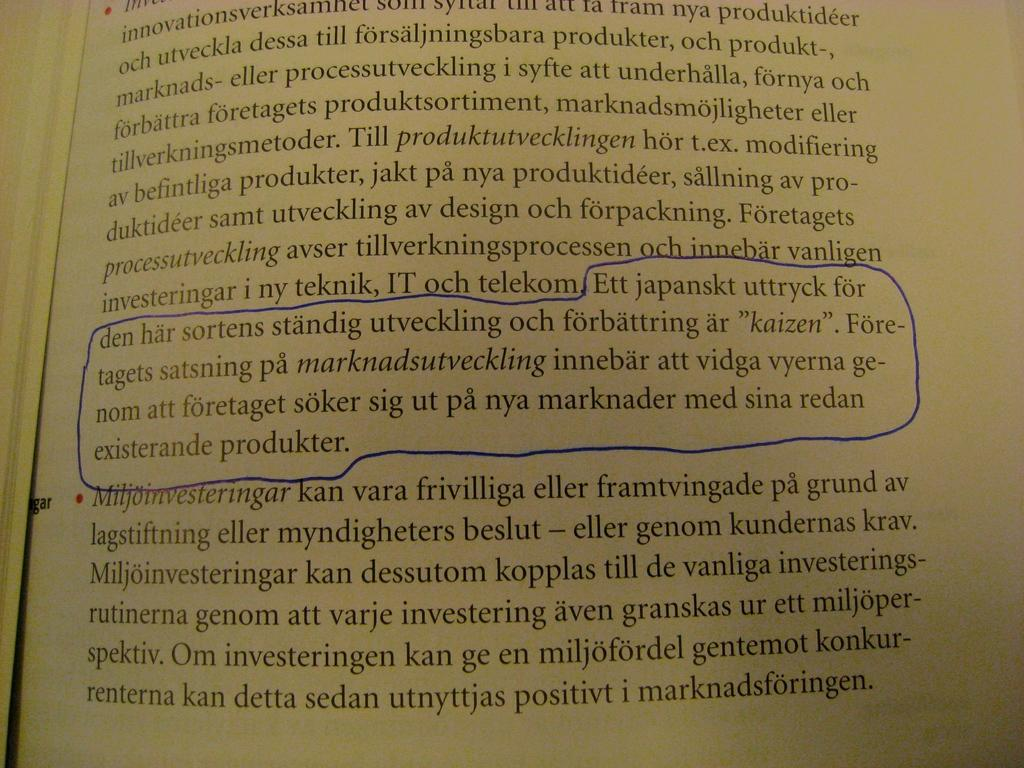<image>
Describe the image concisely. A page is open in a book about telekom 